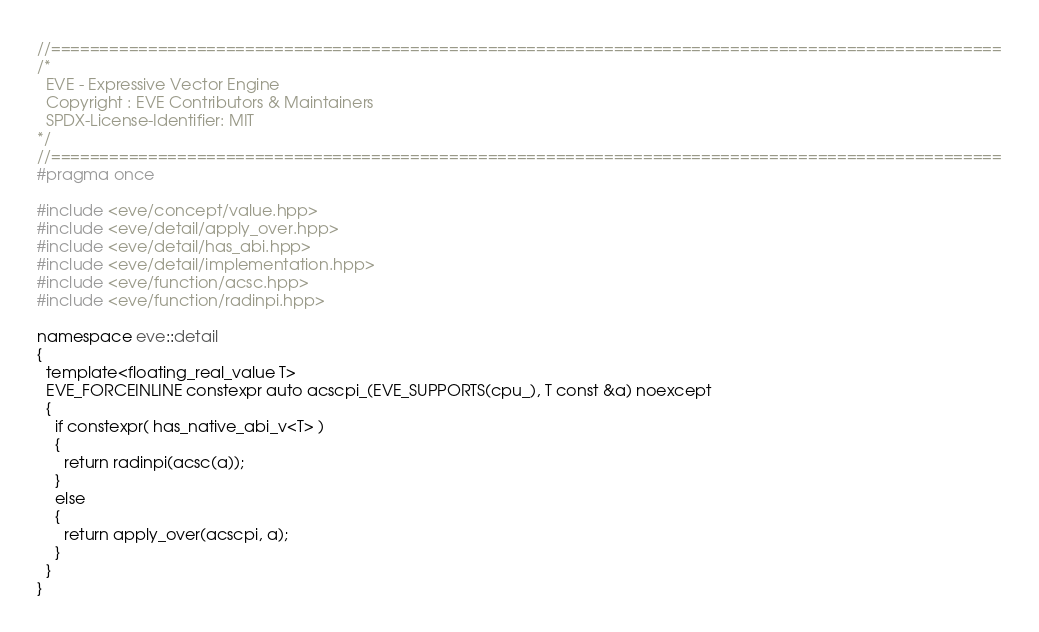<code> <loc_0><loc_0><loc_500><loc_500><_C++_>//==================================================================================================
/*
  EVE - Expressive Vector Engine
  Copyright : EVE Contributors & Maintainers
  SPDX-License-Identifier: MIT
*/
//==================================================================================================
#pragma once

#include <eve/concept/value.hpp>
#include <eve/detail/apply_over.hpp>
#include <eve/detail/has_abi.hpp>
#include <eve/detail/implementation.hpp>
#include <eve/function/acsc.hpp>
#include <eve/function/radinpi.hpp>

namespace eve::detail
{
  template<floating_real_value T>
  EVE_FORCEINLINE constexpr auto acscpi_(EVE_SUPPORTS(cpu_), T const &a) noexcept
  {
    if constexpr( has_native_abi_v<T> )
    {
      return radinpi(acsc(a));
    }
    else
    {
      return apply_over(acscpi, a);
    }
  }
}

</code> 